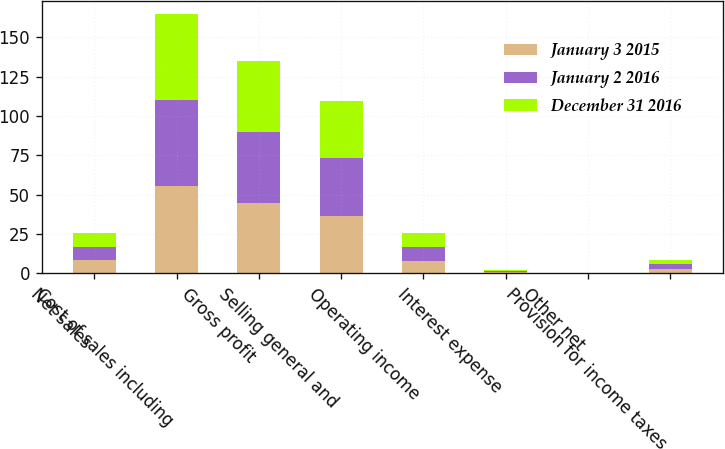Convert chart to OTSL. <chart><loc_0><loc_0><loc_500><loc_500><stacked_bar_chart><ecel><fcel>Net sales<fcel>Cost of sales including<fcel>Gross profit<fcel>Selling general and<fcel>Operating income<fcel>Interest expense<fcel>Other net<fcel>Provision for income taxes<nl><fcel>January 3 2015<fcel>8.5<fcel>55.5<fcel>44.5<fcel>36.3<fcel>8.2<fcel>0.6<fcel>0.1<fcel>2.9<nl><fcel>January 2 2016<fcel>8.5<fcel>54.6<fcel>45.4<fcel>36.9<fcel>8.5<fcel>0.7<fcel>0.1<fcel>2.9<nl><fcel>December 31 2016<fcel>8.5<fcel>54.8<fcel>45.2<fcel>36.6<fcel>8.7<fcel>0.7<fcel>0<fcel>2.9<nl></chart> 